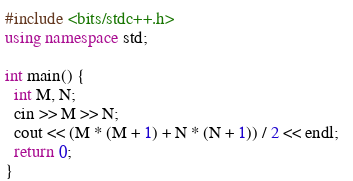Convert code to text. <code><loc_0><loc_0><loc_500><loc_500><_C++_>#include <bits/stdc++.h>
using namespace std;

int main() {
  int M, N;
  cin >> M >> N;
  cout << (M * (M + 1) + N * (N + 1)) / 2 << endl;  
  return 0;
}
</code> 